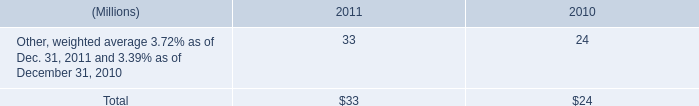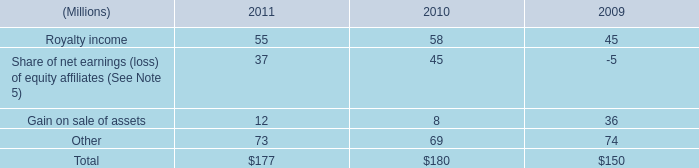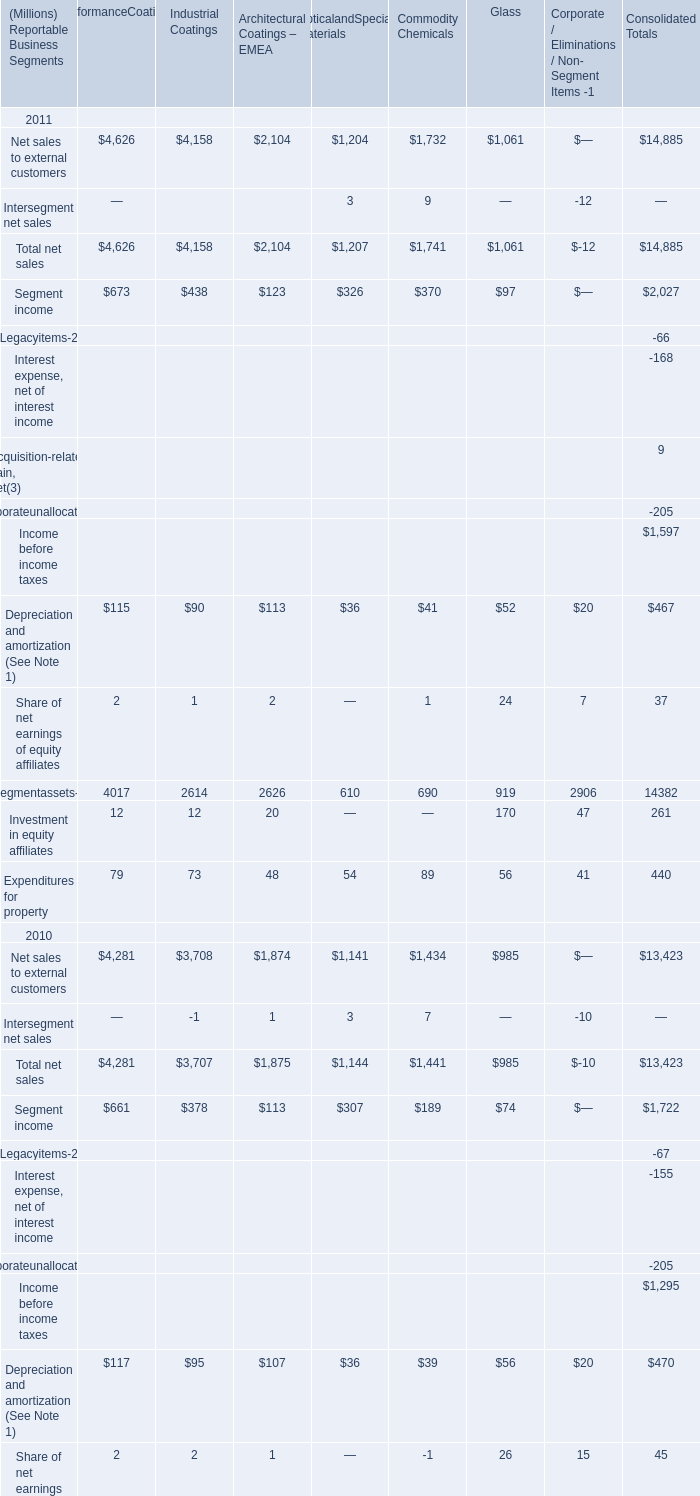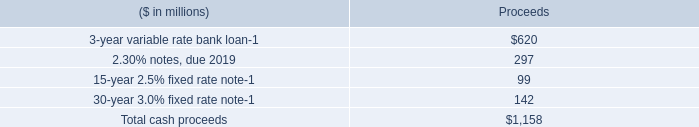what was the percentage change in total interest payments from 2010 to 2011? 
Computations: ((212 - 189) / 189)
Answer: 0.12169. 